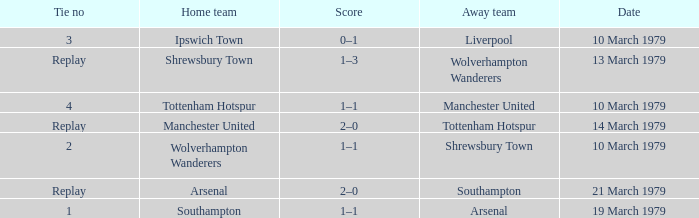Which tie number had an away team of Arsenal? 1.0. Would you mind parsing the complete table? {'header': ['Tie no', 'Home team', 'Score', 'Away team', 'Date'], 'rows': [['3', 'Ipswich Town', '0–1', 'Liverpool', '10 March 1979'], ['Replay', 'Shrewsbury Town', '1–3', 'Wolverhampton Wanderers', '13 March 1979'], ['4', 'Tottenham Hotspur', '1–1', 'Manchester United', '10 March 1979'], ['Replay', 'Manchester United', '2–0', 'Tottenham Hotspur', '14 March 1979'], ['2', 'Wolverhampton Wanderers', '1–1', 'Shrewsbury Town', '10 March 1979'], ['Replay', 'Arsenal', '2–0', 'Southampton', '21 March 1979'], ['1', 'Southampton', '1–1', 'Arsenal', '19 March 1979']]} 